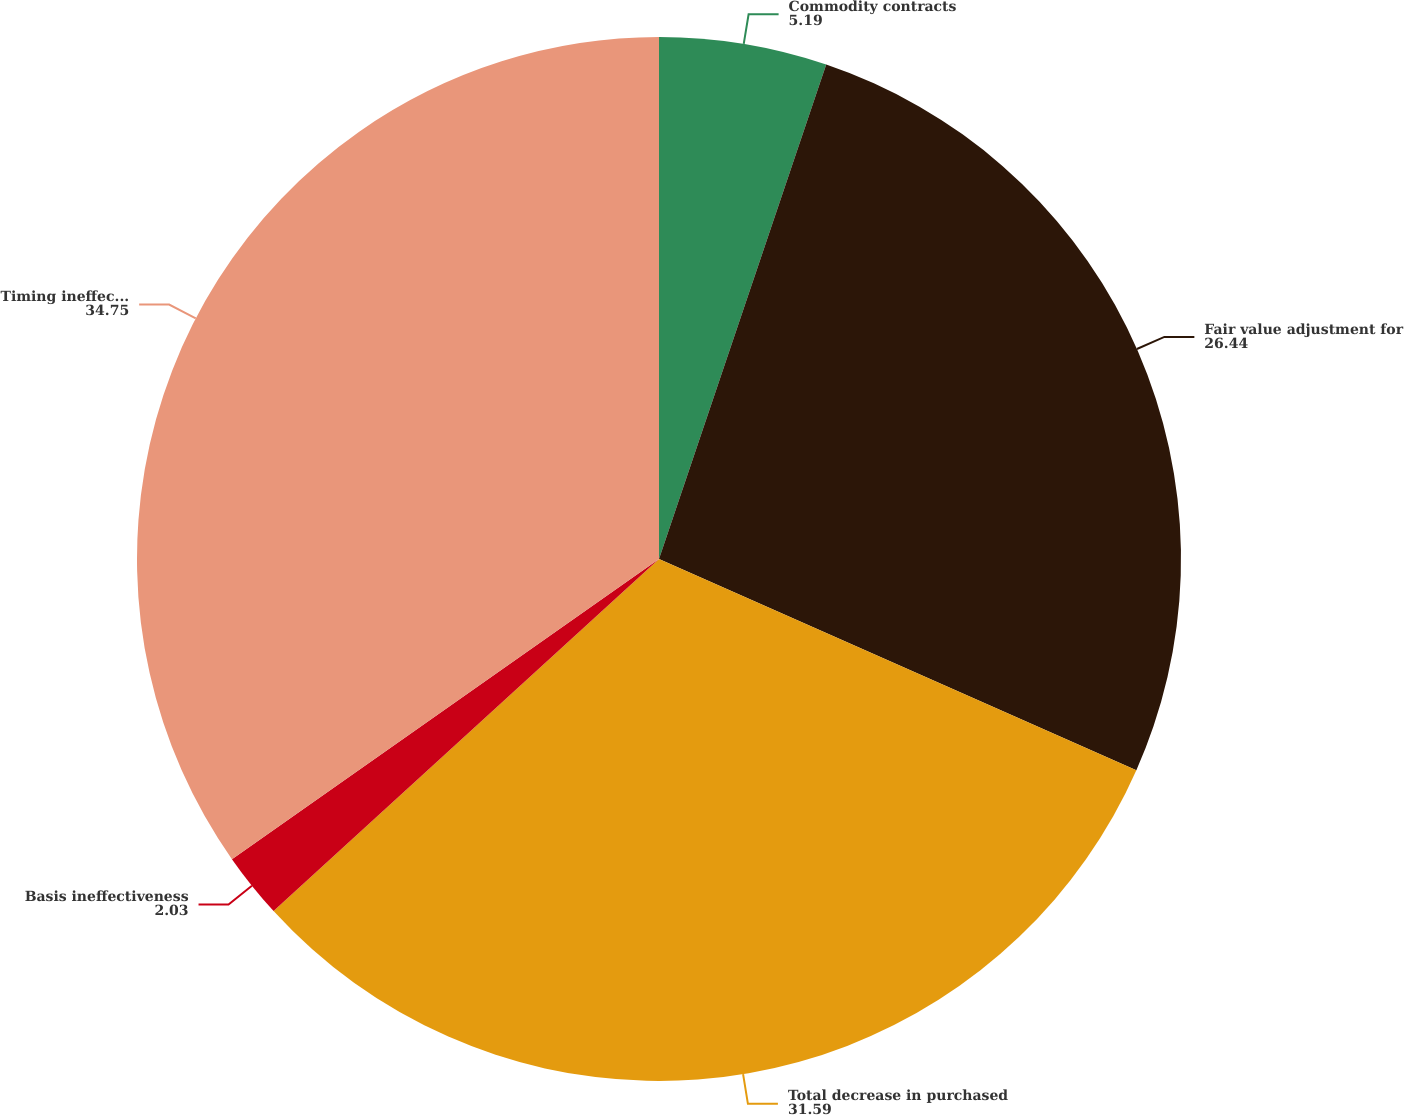<chart> <loc_0><loc_0><loc_500><loc_500><pie_chart><fcel>Commodity contracts<fcel>Fair value adjustment for<fcel>Total decrease in purchased<fcel>Basis ineffectiveness<fcel>Timing ineffectiveness<nl><fcel>5.19%<fcel>26.44%<fcel>31.59%<fcel>2.03%<fcel>34.75%<nl></chart> 